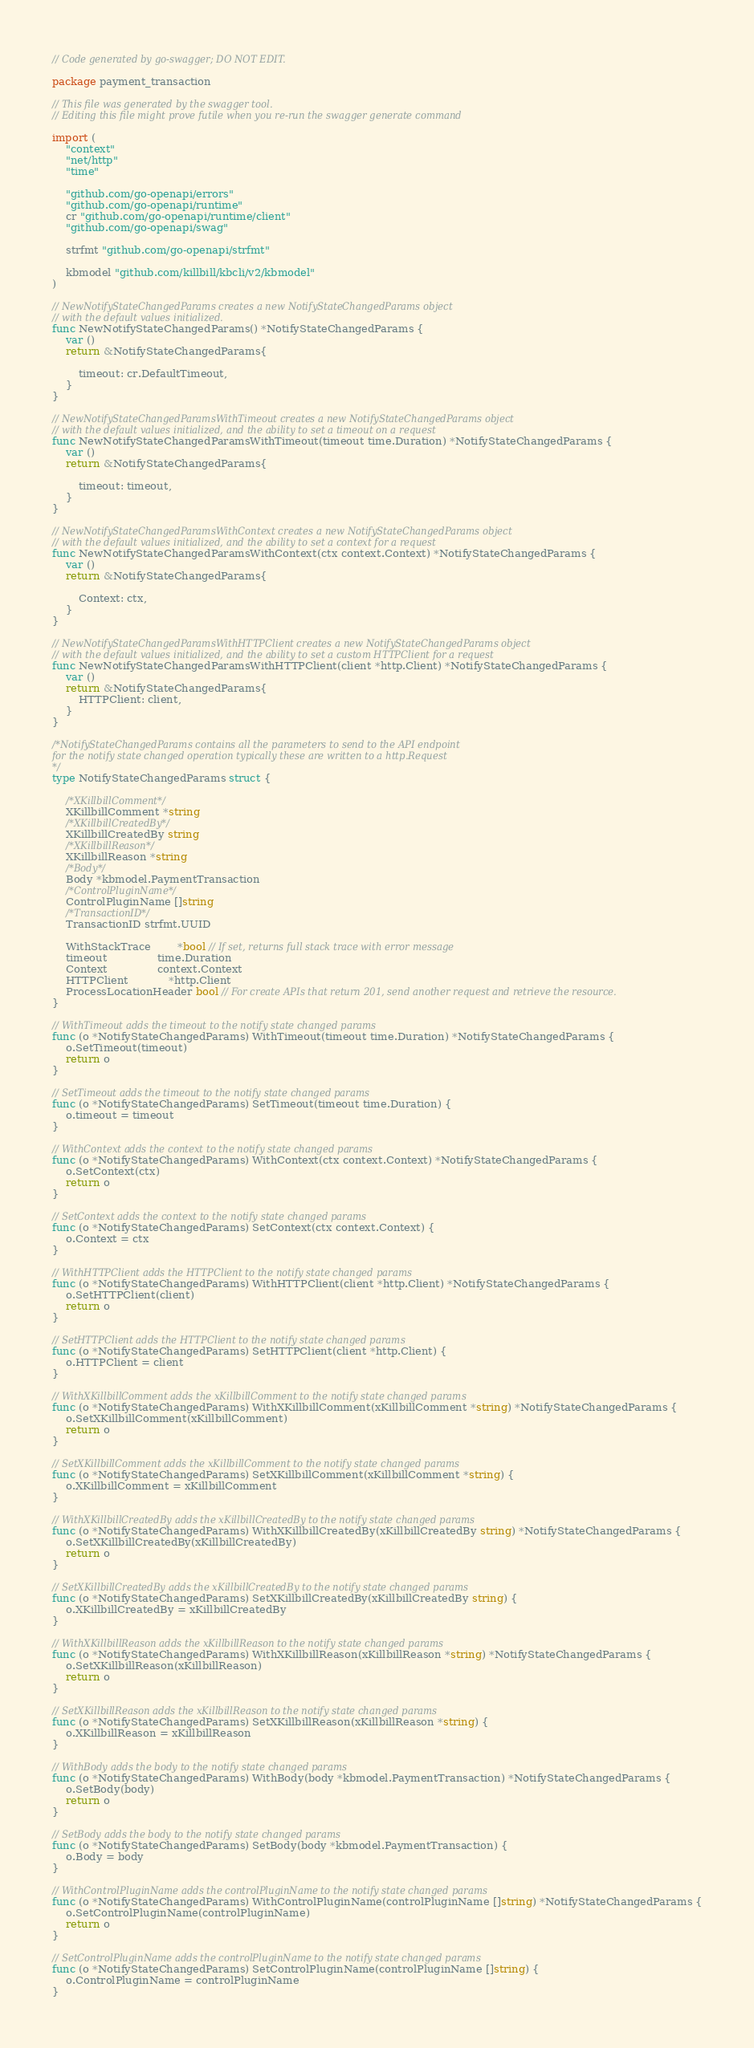<code> <loc_0><loc_0><loc_500><loc_500><_Go_>// Code generated by go-swagger; DO NOT EDIT.

package payment_transaction

// This file was generated by the swagger tool.
// Editing this file might prove futile when you re-run the swagger generate command

import (
	"context"
	"net/http"
	"time"

	"github.com/go-openapi/errors"
	"github.com/go-openapi/runtime"
	cr "github.com/go-openapi/runtime/client"
	"github.com/go-openapi/swag"

	strfmt "github.com/go-openapi/strfmt"

	kbmodel "github.com/killbill/kbcli/v2/kbmodel"
)

// NewNotifyStateChangedParams creates a new NotifyStateChangedParams object
// with the default values initialized.
func NewNotifyStateChangedParams() *NotifyStateChangedParams {
	var ()
	return &NotifyStateChangedParams{

		timeout: cr.DefaultTimeout,
	}
}

// NewNotifyStateChangedParamsWithTimeout creates a new NotifyStateChangedParams object
// with the default values initialized, and the ability to set a timeout on a request
func NewNotifyStateChangedParamsWithTimeout(timeout time.Duration) *NotifyStateChangedParams {
	var ()
	return &NotifyStateChangedParams{

		timeout: timeout,
	}
}

// NewNotifyStateChangedParamsWithContext creates a new NotifyStateChangedParams object
// with the default values initialized, and the ability to set a context for a request
func NewNotifyStateChangedParamsWithContext(ctx context.Context) *NotifyStateChangedParams {
	var ()
	return &NotifyStateChangedParams{

		Context: ctx,
	}
}

// NewNotifyStateChangedParamsWithHTTPClient creates a new NotifyStateChangedParams object
// with the default values initialized, and the ability to set a custom HTTPClient for a request
func NewNotifyStateChangedParamsWithHTTPClient(client *http.Client) *NotifyStateChangedParams {
	var ()
	return &NotifyStateChangedParams{
		HTTPClient: client,
	}
}

/*NotifyStateChangedParams contains all the parameters to send to the API endpoint
for the notify state changed operation typically these are written to a http.Request
*/
type NotifyStateChangedParams struct {

	/*XKillbillComment*/
	XKillbillComment *string
	/*XKillbillCreatedBy*/
	XKillbillCreatedBy string
	/*XKillbillReason*/
	XKillbillReason *string
	/*Body*/
	Body *kbmodel.PaymentTransaction
	/*ControlPluginName*/
	ControlPluginName []string
	/*TransactionID*/
	TransactionID strfmt.UUID

	WithStackTrace        *bool // If set, returns full stack trace with error message
	timeout               time.Duration
	Context               context.Context
	HTTPClient            *http.Client
	ProcessLocationHeader bool // For create APIs that return 201, send another request and retrieve the resource.
}

// WithTimeout adds the timeout to the notify state changed params
func (o *NotifyStateChangedParams) WithTimeout(timeout time.Duration) *NotifyStateChangedParams {
	o.SetTimeout(timeout)
	return o
}

// SetTimeout adds the timeout to the notify state changed params
func (o *NotifyStateChangedParams) SetTimeout(timeout time.Duration) {
	o.timeout = timeout
}

// WithContext adds the context to the notify state changed params
func (o *NotifyStateChangedParams) WithContext(ctx context.Context) *NotifyStateChangedParams {
	o.SetContext(ctx)
	return o
}

// SetContext adds the context to the notify state changed params
func (o *NotifyStateChangedParams) SetContext(ctx context.Context) {
	o.Context = ctx
}

// WithHTTPClient adds the HTTPClient to the notify state changed params
func (o *NotifyStateChangedParams) WithHTTPClient(client *http.Client) *NotifyStateChangedParams {
	o.SetHTTPClient(client)
	return o
}

// SetHTTPClient adds the HTTPClient to the notify state changed params
func (o *NotifyStateChangedParams) SetHTTPClient(client *http.Client) {
	o.HTTPClient = client
}

// WithXKillbillComment adds the xKillbillComment to the notify state changed params
func (o *NotifyStateChangedParams) WithXKillbillComment(xKillbillComment *string) *NotifyStateChangedParams {
	o.SetXKillbillComment(xKillbillComment)
	return o
}

// SetXKillbillComment adds the xKillbillComment to the notify state changed params
func (o *NotifyStateChangedParams) SetXKillbillComment(xKillbillComment *string) {
	o.XKillbillComment = xKillbillComment
}

// WithXKillbillCreatedBy adds the xKillbillCreatedBy to the notify state changed params
func (o *NotifyStateChangedParams) WithXKillbillCreatedBy(xKillbillCreatedBy string) *NotifyStateChangedParams {
	o.SetXKillbillCreatedBy(xKillbillCreatedBy)
	return o
}

// SetXKillbillCreatedBy adds the xKillbillCreatedBy to the notify state changed params
func (o *NotifyStateChangedParams) SetXKillbillCreatedBy(xKillbillCreatedBy string) {
	o.XKillbillCreatedBy = xKillbillCreatedBy
}

// WithXKillbillReason adds the xKillbillReason to the notify state changed params
func (o *NotifyStateChangedParams) WithXKillbillReason(xKillbillReason *string) *NotifyStateChangedParams {
	o.SetXKillbillReason(xKillbillReason)
	return o
}

// SetXKillbillReason adds the xKillbillReason to the notify state changed params
func (o *NotifyStateChangedParams) SetXKillbillReason(xKillbillReason *string) {
	o.XKillbillReason = xKillbillReason
}

// WithBody adds the body to the notify state changed params
func (o *NotifyStateChangedParams) WithBody(body *kbmodel.PaymentTransaction) *NotifyStateChangedParams {
	o.SetBody(body)
	return o
}

// SetBody adds the body to the notify state changed params
func (o *NotifyStateChangedParams) SetBody(body *kbmodel.PaymentTransaction) {
	o.Body = body
}

// WithControlPluginName adds the controlPluginName to the notify state changed params
func (o *NotifyStateChangedParams) WithControlPluginName(controlPluginName []string) *NotifyStateChangedParams {
	o.SetControlPluginName(controlPluginName)
	return o
}

// SetControlPluginName adds the controlPluginName to the notify state changed params
func (o *NotifyStateChangedParams) SetControlPluginName(controlPluginName []string) {
	o.ControlPluginName = controlPluginName
}
</code> 